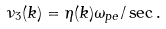<formula> <loc_0><loc_0><loc_500><loc_500>\nu _ { 3 } ( k ) = \eta ( k ) \omega _ { p e } / \sec .</formula> 